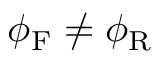Convert formula to latex. <formula><loc_0><loc_0><loc_500><loc_500>\phi _ { F } \neq \phi _ { R }</formula> 